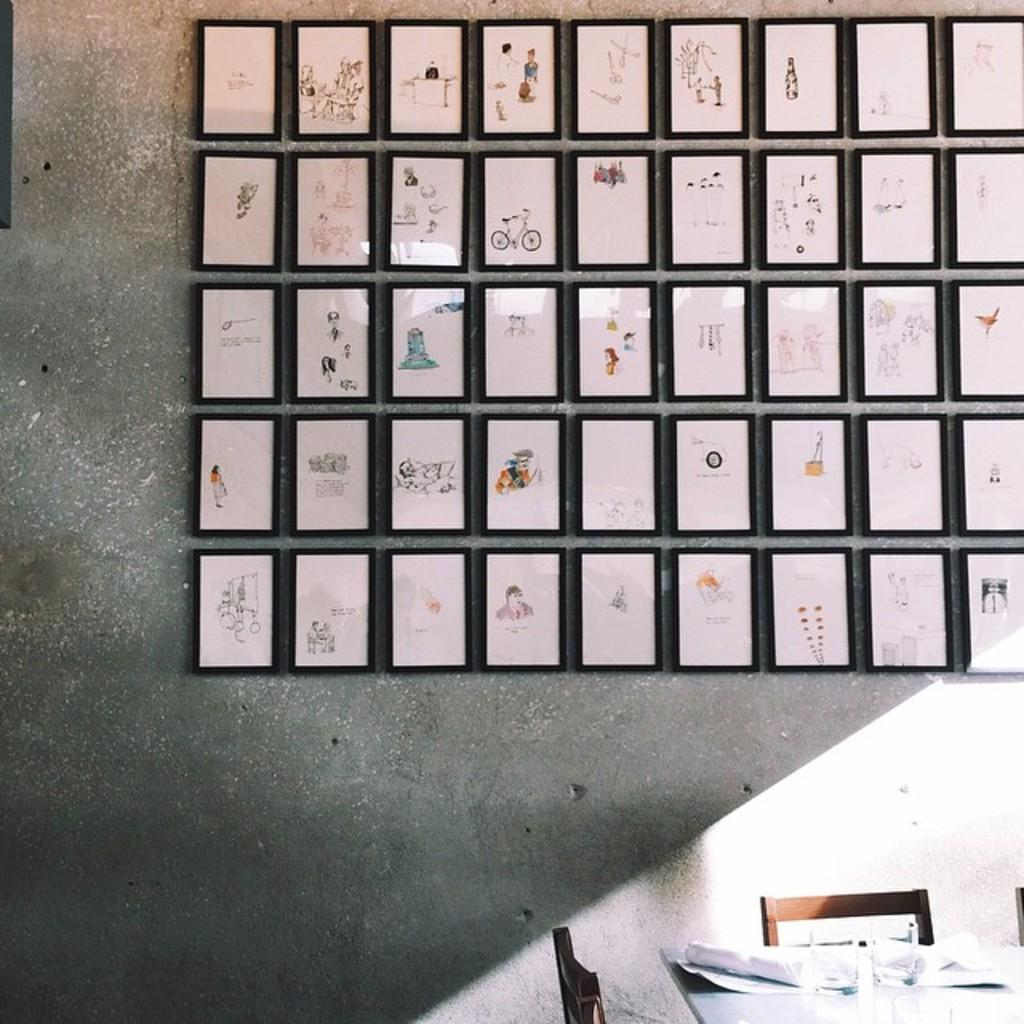What is present on the wall in the image? There are photo frames on the wall. What is located in front of the wall? There is a table in front of the wall. What can be seen on the table? There are papers on the table. What type of furniture is present around the table? There are chairs around the table. How does the mist affect the growth of the photo frames on the wall? There is no mist present in the image, and therefore it cannot affect the growth of the photo frames. What type of adjustment is needed for the chairs around the table? The chairs around the table do not require any adjustment, as they are already positioned around the table. 